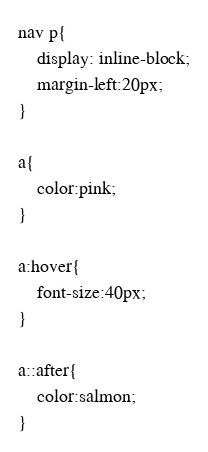Convert code to text. <code><loc_0><loc_0><loc_500><loc_500><_CSS_>
nav p{
    display: inline-block;
    margin-left:20px;
}

a{
    color:pink;
}

a:hover{
    font-size:40px;
}

a::after{
    color:salmon;
}</code> 